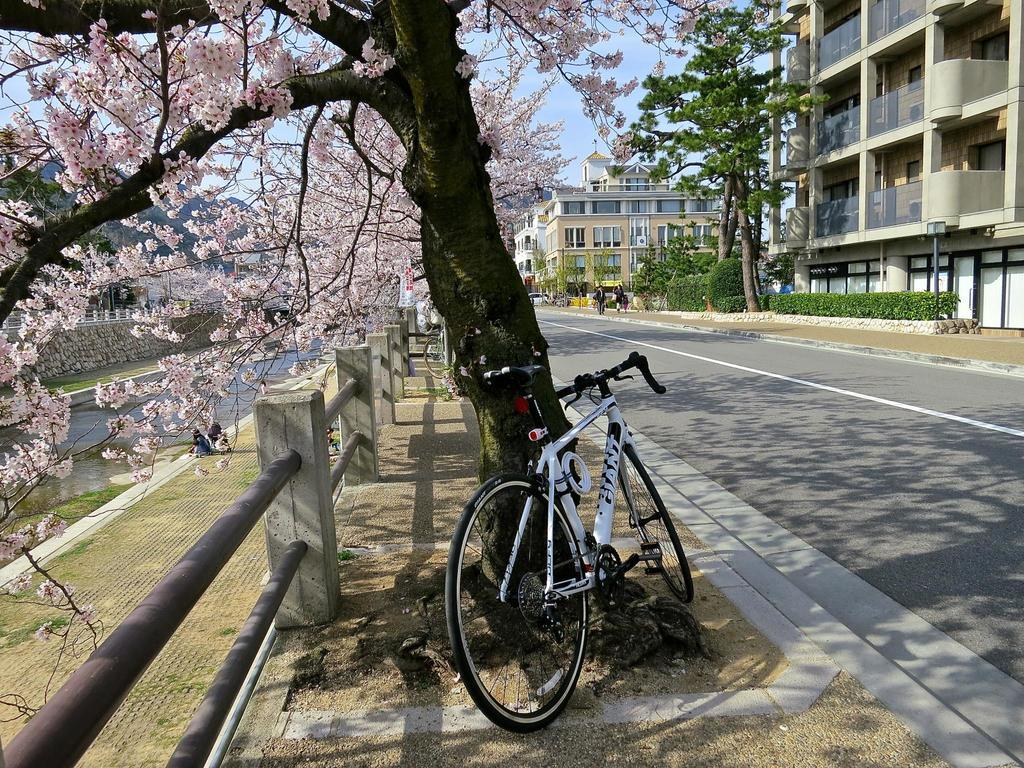What type of vegetation can be seen in the image? There are trees and plants visible in the image. What object is located beside the tree? There is a bicycle beside the tree. What type of structure is present in the image? There is a fence in the image. What type of man-made structures can be seen in the image? There are buildings visible in the image. What type of vertical structure is present in the image? There is a light pole in the image. Are there any people visible in the image? Yes, there are people visible in the distance. How many crackers are being eaten by the frogs in the image? There are no crackers or frogs present in the image. What type of person is standing next to the tree in the image? There is no person standing next to the tree in the image; only a bicycle is present beside the tree. 